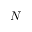<formula> <loc_0><loc_0><loc_500><loc_500>N</formula> 